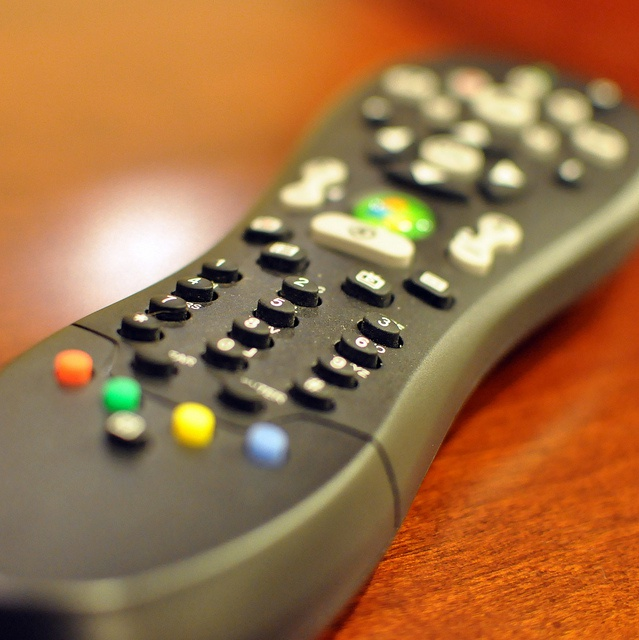Describe the objects in this image and their specific colors. I can see a remote in orange, gray, and tan tones in this image. 